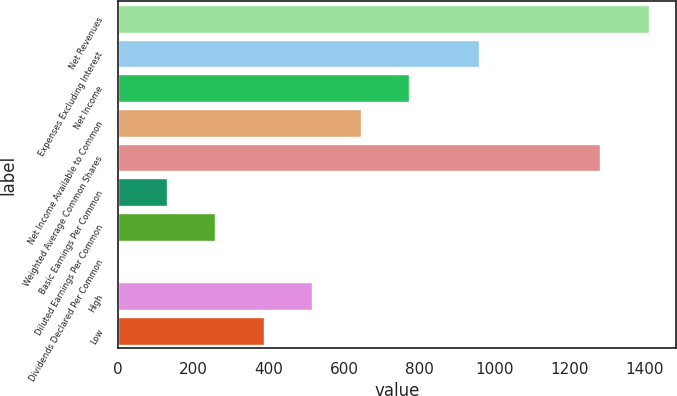Convert chart. <chart><loc_0><loc_0><loc_500><loc_500><bar_chart><fcel>Net Revenues<fcel>Expenses Excluding Interest<fcel>Net Income<fcel>Net Income Available to Common<fcel>Weighted Average Common Shares<fcel>Basic Earnings Per Common<fcel>Diluted Earnings Per Common<fcel>Dividends Declared Per Common<fcel>High<fcel>Low<nl><fcel>1410.99<fcel>959<fcel>774<fcel>645.01<fcel>1282<fcel>129.05<fcel>258.04<fcel>0.06<fcel>516.02<fcel>387.03<nl></chart> 